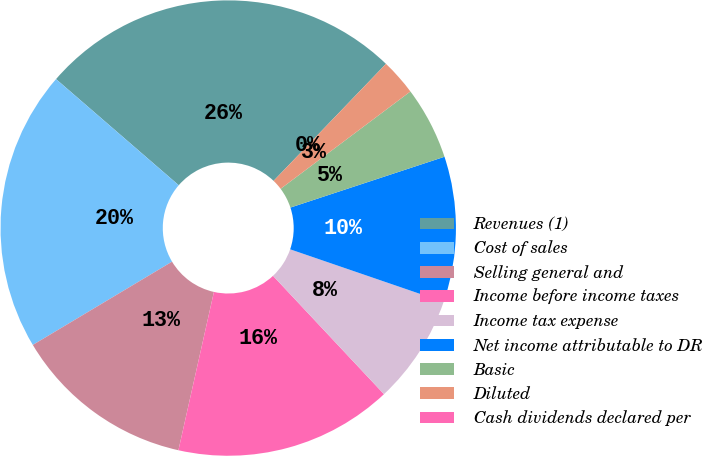Convert chart. <chart><loc_0><loc_0><loc_500><loc_500><pie_chart><fcel>Revenues (1)<fcel>Cost of sales<fcel>Selling general and<fcel>Income before income taxes<fcel>Income tax expense<fcel>Net income attributable to DR<fcel>Basic<fcel>Diluted<fcel>Cash dividends declared per<nl><fcel>25.83%<fcel>19.93%<fcel>12.91%<fcel>15.5%<fcel>7.75%<fcel>10.33%<fcel>5.17%<fcel>2.58%<fcel>0.0%<nl></chart> 